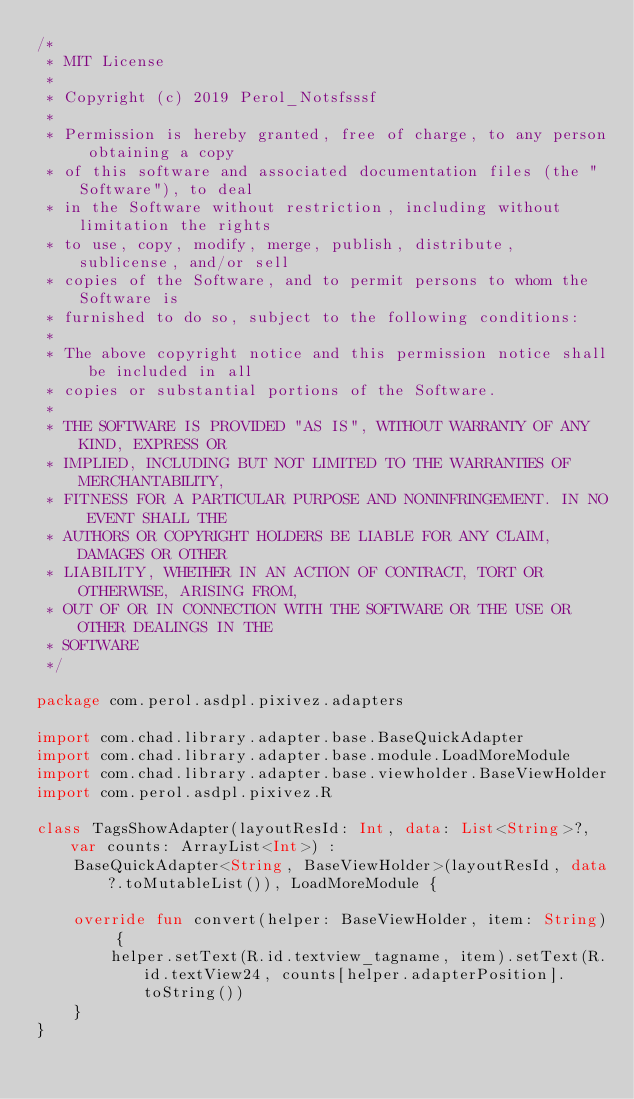Convert code to text. <code><loc_0><loc_0><loc_500><loc_500><_Kotlin_>/*
 * MIT License
 *
 * Copyright (c) 2019 Perol_Notsfsssf
 *
 * Permission is hereby granted, free of charge, to any person obtaining a copy
 * of this software and associated documentation files (the "Software"), to deal
 * in the Software without restriction, including without limitation the rights
 * to use, copy, modify, merge, publish, distribute, sublicense, and/or sell
 * copies of the Software, and to permit persons to whom the Software is
 * furnished to do so, subject to the following conditions:
 *
 * The above copyright notice and this permission notice shall be included in all
 * copies or substantial portions of the Software.
 *
 * THE SOFTWARE IS PROVIDED "AS IS", WITHOUT WARRANTY OF ANY KIND, EXPRESS OR
 * IMPLIED, INCLUDING BUT NOT LIMITED TO THE WARRANTIES OF MERCHANTABILITY,
 * FITNESS FOR A PARTICULAR PURPOSE AND NONINFRINGEMENT. IN NO EVENT SHALL THE
 * AUTHORS OR COPYRIGHT HOLDERS BE LIABLE FOR ANY CLAIM, DAMAGES OR OTHER
 * LIABILITY, WHETHER IN AN ACTION OF CONTRACT, TORT OR OTHERWISE, ARISING FROM,
 * OUT OF OR IN CONNECTION WITH THE SOFTWARE OR THE USE OR OTHER DEALINGS IN THE
 * SOFTWARE
 */

package com.perol.asdpl.pixivez.adapters

import com.chad.library.adapter.base.BaseQuickAdapter
import com.chad.library.adapter.base.module.LoadMoreModule
import com.chad.library.adapter.base.viewholder.BaseViewHolder
import com.perol.asdpl.pixivez.R

class TagsShowAdapter(layoutResId: Int, data: List<String>?, var counts: ArrayList<Int>) :
    BaseQuickAdapter<String, BaseViewHolder>(layoutResId, data?.toMutableList()), LoadMoreModule {

    override fun convert(helper: BaseViewHolder, item: String) {
        helper.setText(R.id.textview_tagname, item).setText(R.id.textView24, counts[helper.adapterPosition].toString())
    }
}
</code> 